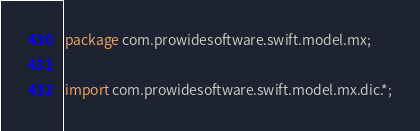<code> <loc_0><loc_0><loc_500><loc_500><_Java_>
package com.prowidesoftware.swift.model.mx;

import com.prowidesoftware.swift.model.mx.dic.*;</code> 